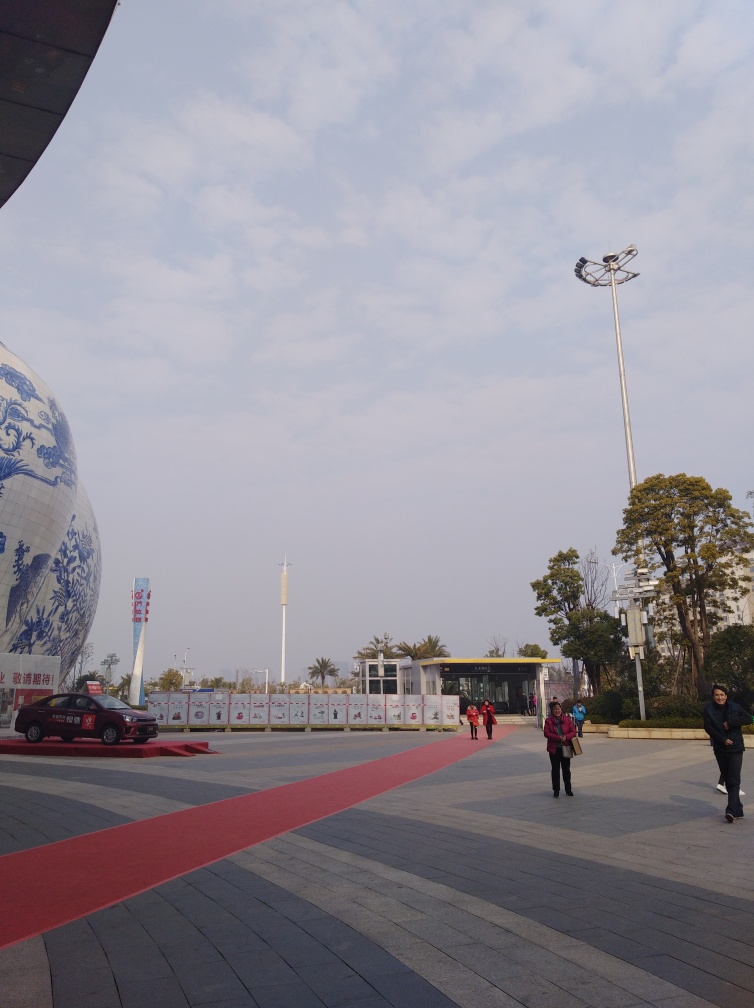What might be the significance of the large sphere in the image? The large sphere seems to feature blue and white porcelain designs, which are traditional in some cultures and often seen as a symbol of refined artistry and craftsmanship. It may be an art installation or part of a museum exhibit, serving as an iconic landmark and promoting cultural heritage. 